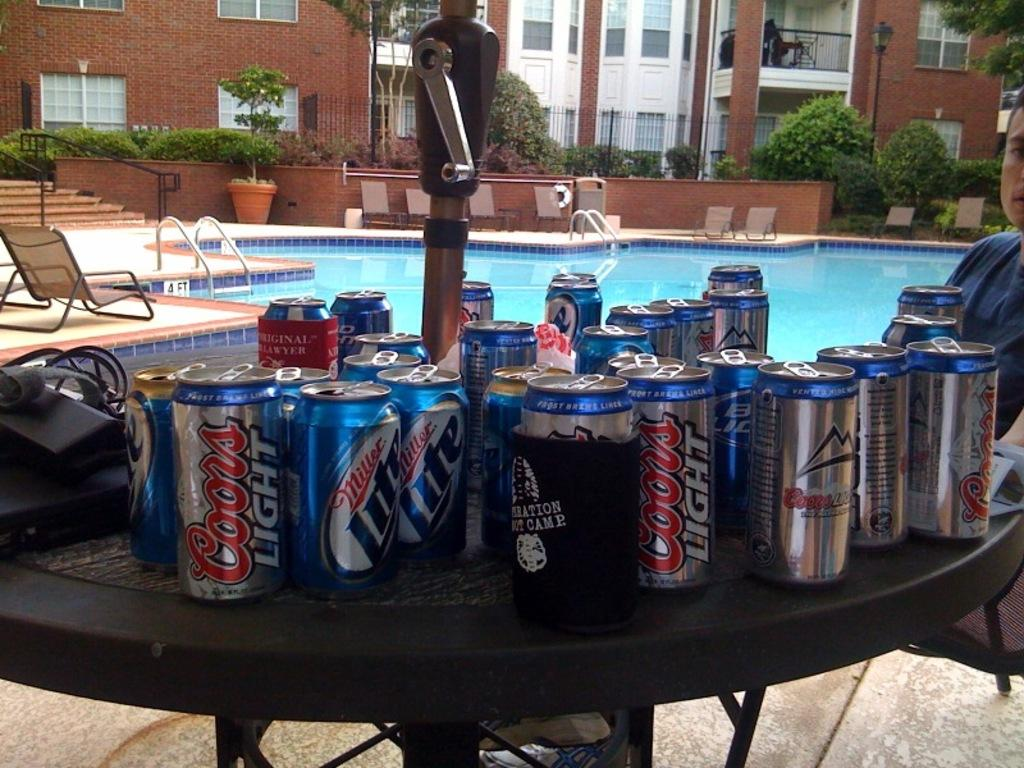<image>
Share a concise interpretation of the image provided. A table full of empty cans of Coors Light and Miller Lite. 